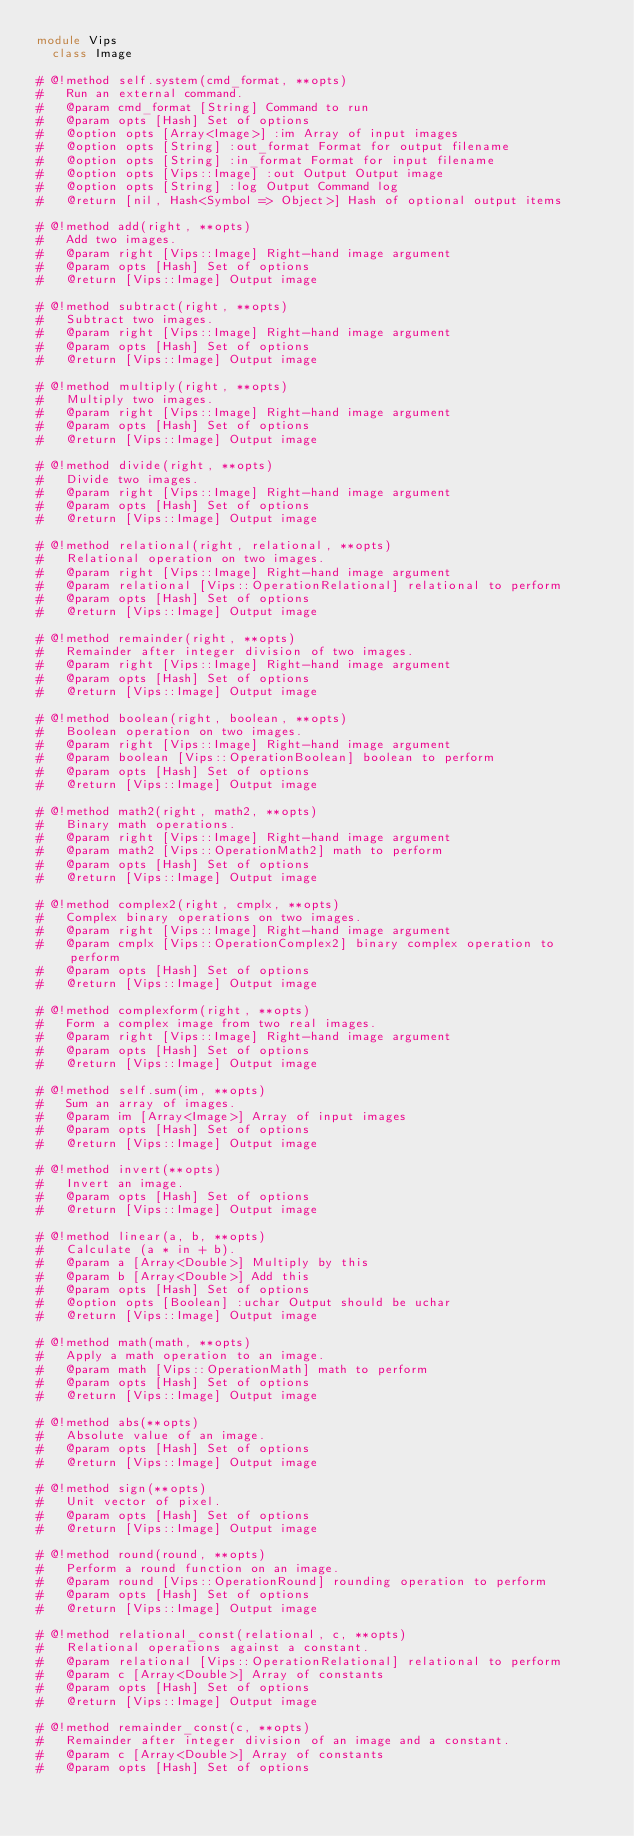<code> <loc_0><loc_0><loc_500><loc_500><_Ruby_>module Vips
  class Image

# @!method self.system(cmd_format, **opts)
#   Run an external command.
#   @param cmd_format [String] Command to run
#   @param opts [Hash] Set of options
#   @option opts [Array<Image>] :im Array of input images
#   @option opts [String] :out_format Format for output filename
#   @option opts [String] :in_format Format for input filename
#   @option opts [Vips::Image] :out Output Output image
#   @option opts [String] :log Output Command log
#   @return [nil, Hash<Symbol => Object>] Hash of optional output items

# @!method add(right, **opts)
#   Add two images.
#   @param right [Vips::Image] Right-hand image argument
#   @param opts [Hash] Set of options
#   @return [Vips::Image] Output image

# @!method subtract(right, **opts)
#   Subtract two images.
#   @param right [Vips::Image] Right-hand image argument
#   @param opts [Hash] Set of options
#   @return [Vips::Image] Output image

# @!method multiply(right, **opts)
#   Multiply two images.
#   @param right [Vips::Image] Right-hand image argument
#   @param opts [Hash] Set of options
#   @return [Vips::Image] Output image

# @!method divide(right, **opts)
#   Divide two images.
#   @param right [Vips::Image] Right-hand image argument
#   @param opts [Hash] Set of options
#   @return [Vips::Image] Output image

# @!method relational(right, relational, **opts)
#   Relational operation on two images.
#   @param right [Vips::Image] Right-hand image argument
#   @param relational [Vips::OperationRelational] relational to perform
#   @param opts [Hash] Set of options
#   @return [Vips::Image] Output image

# @!method remainder(right, **opts)
#   Remainder after integer division of two images.
#   @param right [Vips::Image] Right-hand image argument
#   @param opts [Hash] Set of options
#   @return [Vips::Image] Output image

# @!method boolean(right, boolean, **opts)
#   Boolean operation on two images.
#   @param right [Vips::Image] Right-hand image argument
#   @param boolean [Vips::OperationBoolean] boolean to perform
#   @param opts [Hash] Set of options
#   @return [Vips::Image] Output image

# @!method math2(right, math2, **opts)
#   Binary math operations.
#   @param right [Vips::Image] Right-hand image argument
#   @param math2 [Vips::OperationMath2] math to perform
#   @param opts [Hash] Set of options
#   @return [Vips::Image] Output image

# @!method complex2(right, cmplx, **opts)
#   Complex binary operations on two images.
#   @param right [Vips::Image] Right-hand image argument
#   @param cmplx [Vips::OperationComplex2] binary complex operation to perform
#   @param opts [Hash] Set of options
#   @return [Vips::Image] Output image

# @!method complexform(right, **opts)
#   Form a complex image from two real images.
#   @param right [Vips::Image] Right-hand image argument
#   @param opts [Hash] Set of options
#   @return [Vips::Image] Output image

# @!method self.sum(im, **opts)
#   Sum an array of images.
#   @param im [Array<Image>] Array of input images
#   @param opts [Hash] Set of options
#   @return [Vips::Image] Output image

# @!method invert(**opts)
#   Invert an image.
#   @param opts [Hash] Set of options
#   @return [Vips::Image] Output image

# @!method linear(a, b, **opts)
#   Calculate (a * in + b).
#   @param a [Array<Double>] Multiply by this
#   @param b [Array<Double>] Add this
#   @param opts [Hash] Set of options
#   @option opts [Boolean] :uchar Output should be uchar
#   @return [Vips::Image] Output image

# @!method math(math, **opts)
#   Apply a math operation to an image.
#   @param math [Vips::OperationMath] math to perform
#   @param opts [Hash] Set of options
#   @return [Vips::Image] Output image

# @!method abs(**opts)
#   Absolute value of an image.
#   @param opts [Hash] Set of options
#   @return [Vips::Image] Output image

# @!method sign(**opts)
#   Unit vector of pixel.
#   @param opts [Hash] Set of options
#   @return [Vips::Image] Output image

# @!method round(round, **opts)
#   Perform a round function on an image.
#   @param round [Vips::OperationRound] rounding operation to perform
#   @param opts [Hash] Set of options
#   @return [Vips::Image] Output image

# @!method relational_const(relational, c, **opts)
#   Relational operations against a constant.
#   @param relational [Vips::OperationRelational] relational to perform
#   @param c [Array<Double>] Array of constants
#   @param opts [Hash] Set of options
#   @return [Vips::Image] Output image

# @!method remainder_const(c, **opts)
#   Remainder after integer division of an image and a constant.
#   @param c [Array<Double>] Array of constants
#   @param opts [Hash] Set of options</code> 